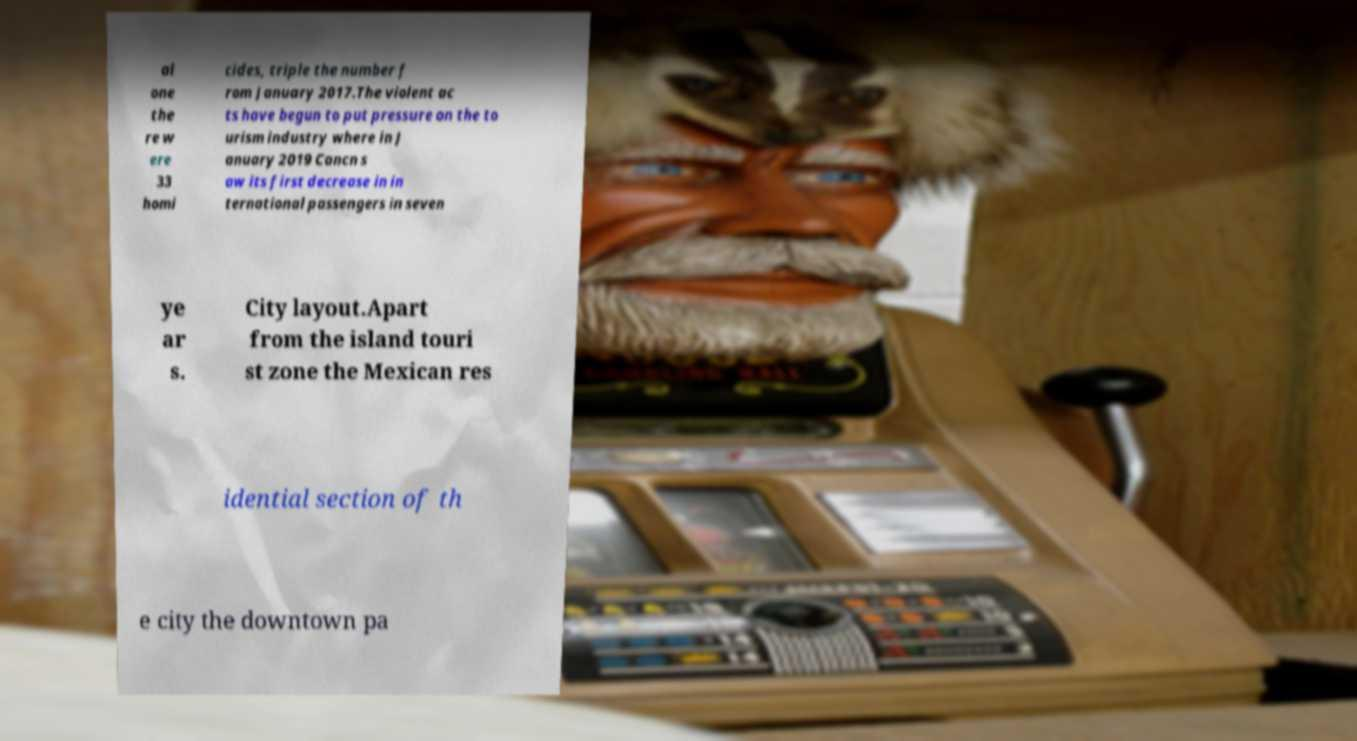I need the written content from this picture converted into text. Can you do that? al one the re w ere 33 homi cides, triple the number f rom January 2017.The violent ac ts have begun to put pressure on the to urism industry where in J anuary 2019 Cancn s aw its first decrease in in ternational passengers in seven ye ar s. City layout.Apart from the island touri st zone the Mexican res idential section of th e city the downtown pa 